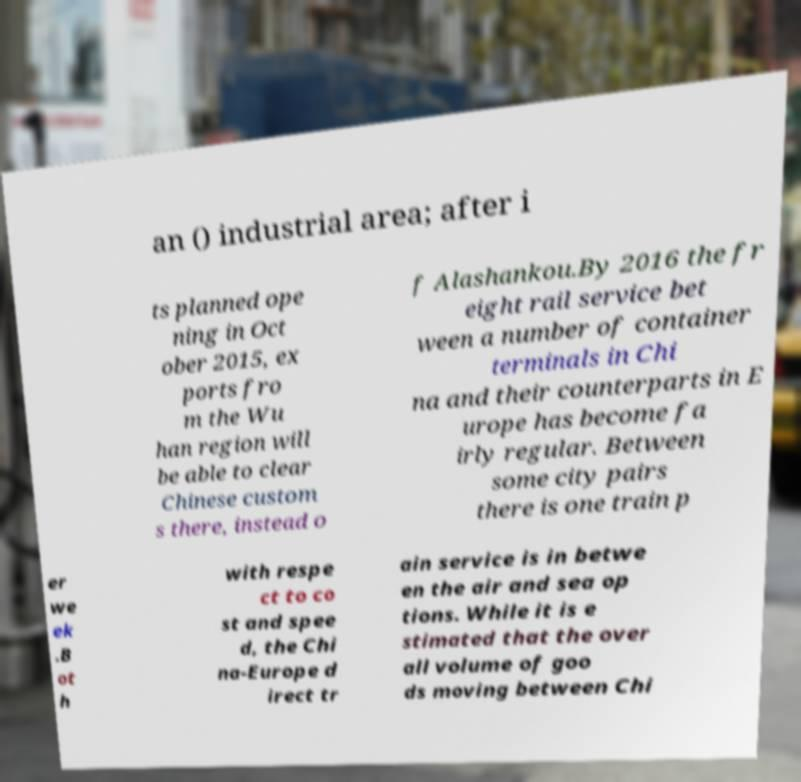I need the written content from this picture converted into text. Can you do that? an () industrial area; after i ts planned ope ning in Oct ober 2015, ex ports fro m the Wu han region will be able to clear Chinese custom s there, instead o f Alashankou.By 2016 the fr eight rail service bet ween a number of container terminals in Chi na and their counterparts in E urope has become fa irly regular. Between some city pairs there is one train p er we ek .B ot h with respe ct to co st and spee d, the Chi na-Europe d irect tr ain service is in betwe en the air and sea op tions. While it is e stimated that the over all volume of goo ds moving between Chi 